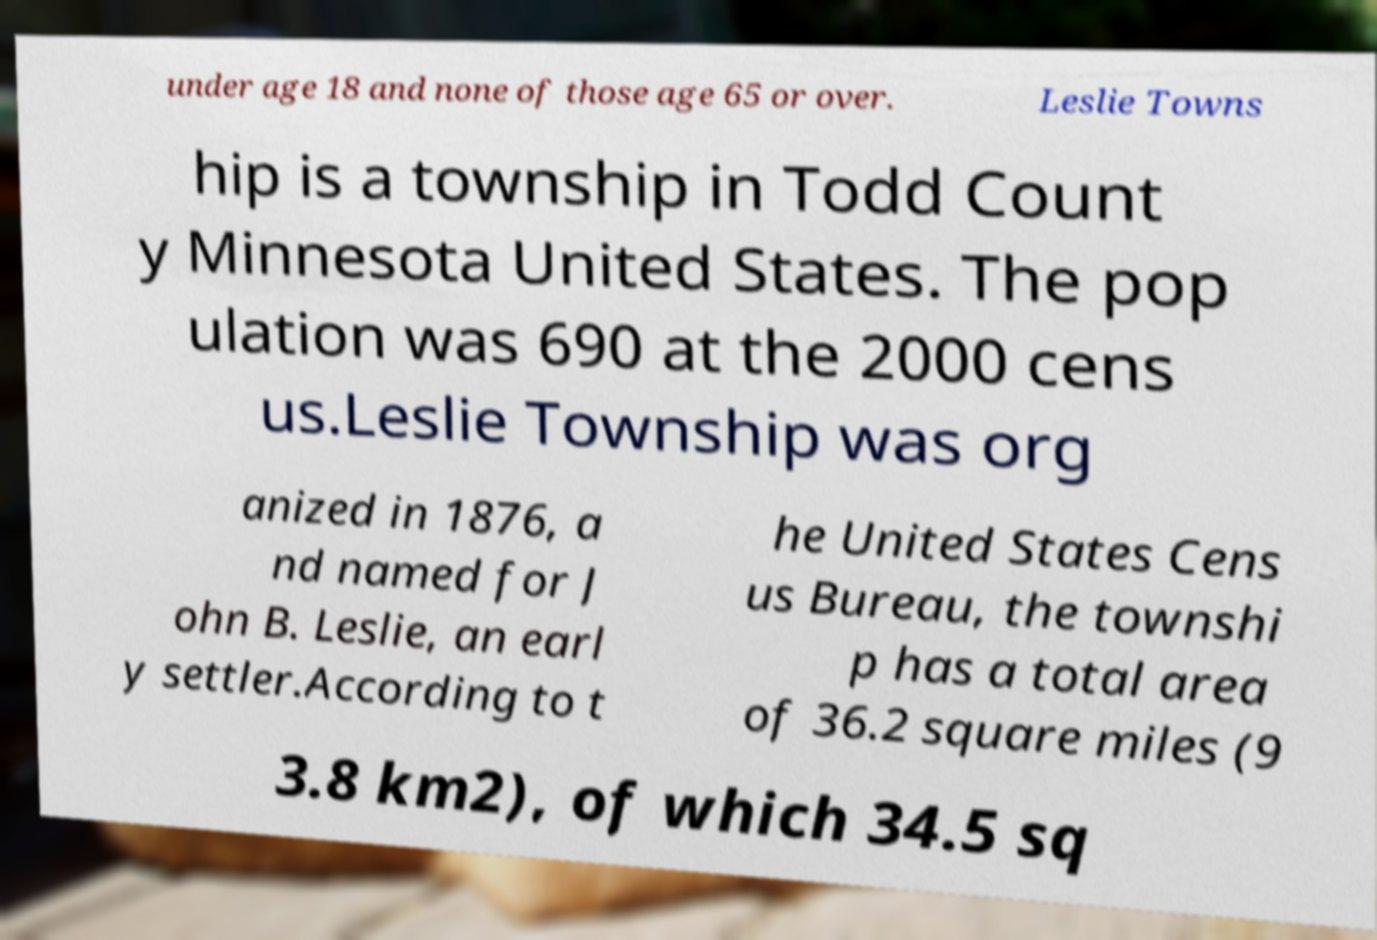Please identify and transcribe the text found in this image. under age 18 and none of those age 65 or over. Leslie Towns hip is a township in Todd Count y Minnesota United States. The pop ulation was 690 at the 2000 cens us.Leslie Township was org anized in 1876, a nd named for J ohn B. Leslie, an earl y settler.According to t he United States Cens us Bureau, the townshi p has a total area of 36.2 square miles (9 3.8 km2), of which 34.5 sq 